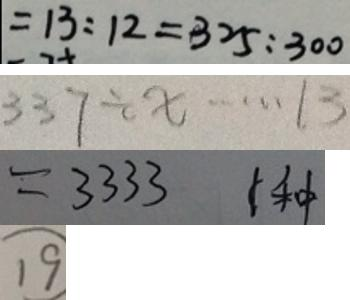Convert formula to latex. <formula><loc_0><loc_0><loc_500><loc_500>= 1 3 : 1 2 = 3 2 5 : 3 0 0 
 3 3 7 \div x \cdots 1 3 
 = 3 3 3 3 1 种 
 \textcircled { 1 9 }</formula> 